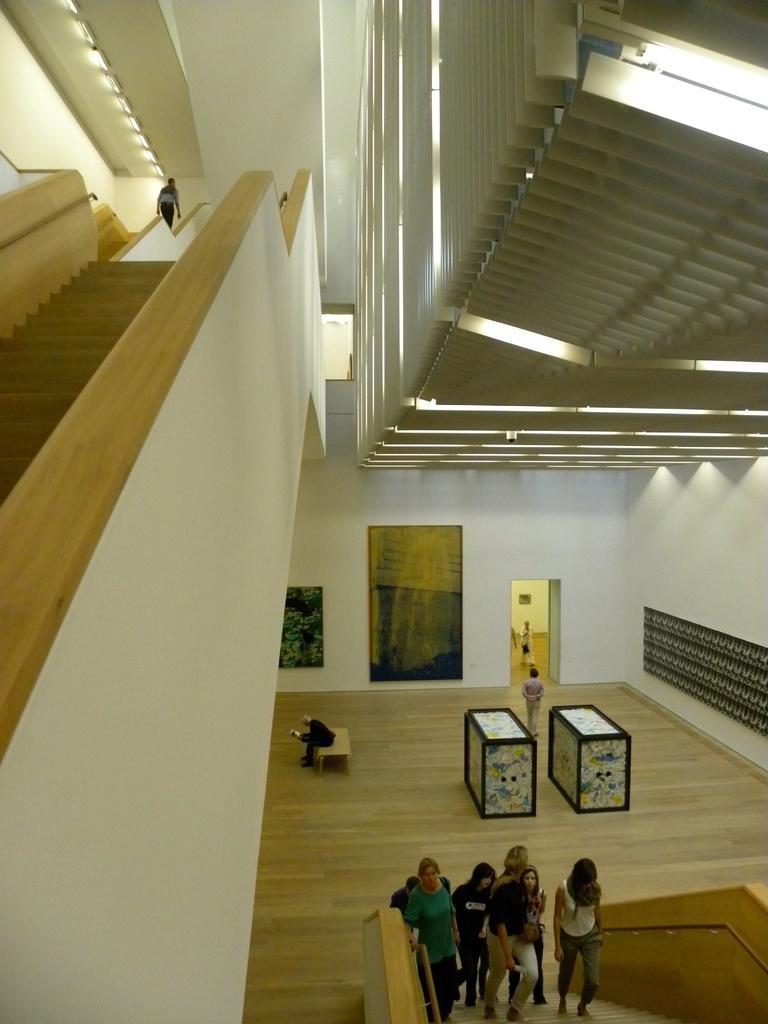Could you give a brief overview of what you see in this image? In this picture, we can see the inside view of a building. At the bottom of the image, a group of people on the stairs. Here we can see the floor, few objects, wall and people. Top of the image, we can see the lights, railings, stairs, wall and person. 